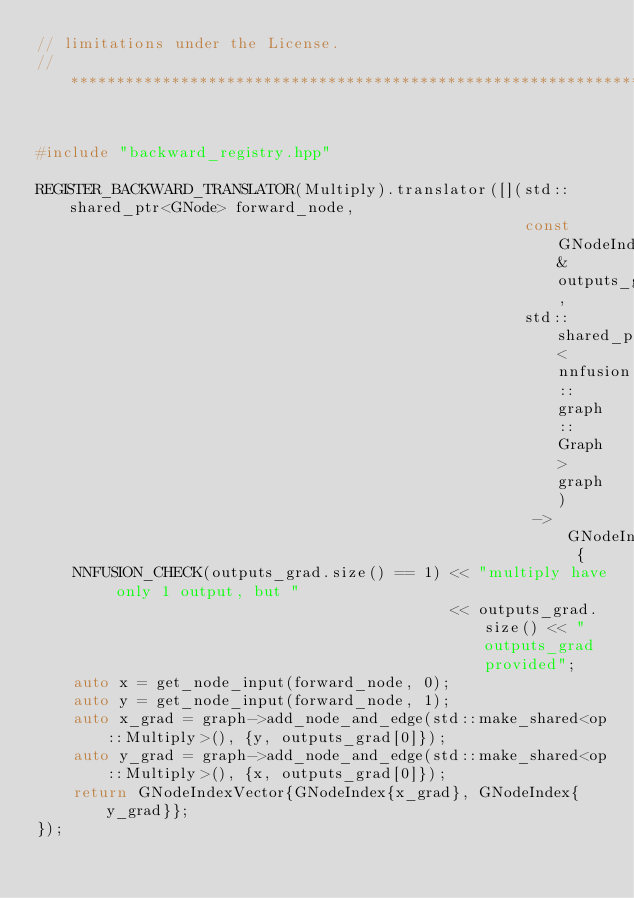Convert code to text. <code><loc_0><loc_0><loc_500><loc_500><_C++_>// limitations under the License.
//*****************************************************************************


#include "backward_registry.hpp"

REGISTER_BACKWARD_TRANSLATOR(Multiply).translator([](std::shared_ptr<GNode> forward_node,
                                                     const GNodeIndexVector& outputs_grad,
                                                     std::shared_ptr<nnfusion::graph::Graph> graph)
                                                      -> GNodeIndexVector {
    NNFUSION_CHECK(outputs_grad.size() == 1) << "multiply have only 1 output, but "
                                             << outputs_grad.size() << " outputs_grad provided";
    auto x = get_node_input(forward_node, 0);
    auto y = get_node_input(forward_node, 1);
    auto x_grad = graph->add_node_and_edge(std::make_shared<op::Multiply>(), {y, outputs_grad[0]});
    auto y_grad = graph->add_node_and_edge(std::make_shared<op::Multiply>(), {x, outputs_grad[0]});
    return GNodeIndexVector{GNodeIndex{x_grad}, GNodeIndex{y_grad}};
});</code> 